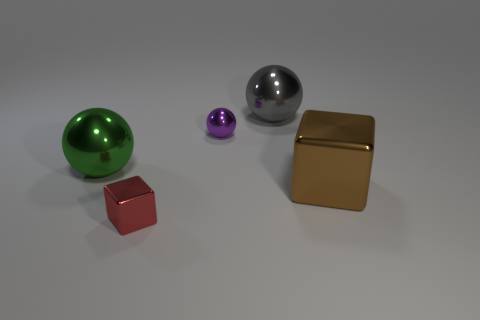Are there any potential uses for these objects, considering their shapes and sizes? Given their shapes and sizes, these objects could serve various functional and decorative purposes. The spherical objects might be ornamental or part of a larger mechanism, while the cube could be a container or packaging. The metallic sheen on some items suggests they could also be awards or part of a modern art installation. Their simplicity opens up a multitude of potential uses, both practical and aesthetic. 